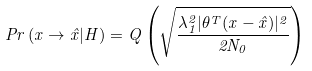<formula> <loc_0><loc_0><loc_500><loc_500>P r \left ( x \rightarrow \hat { x } | H \right ) = Q \left ( \sqrt { \frac { \lambda _ { 1 } ^ { 2 } | \theta ^ { T } ( x - \hat { x } ) | ^ { 2 } } { 2 N _ { 0 } } } \right )</formula> 